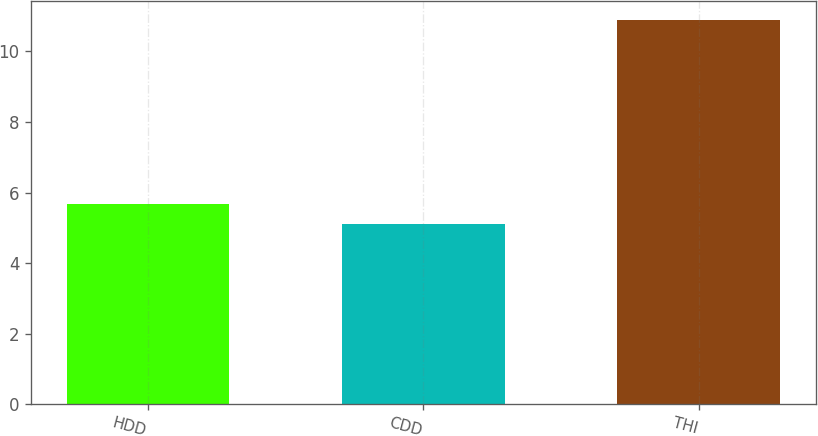Convert chart to OTSL. <chart><loc_0><loc_0><loc_500><loc_500><bar_chart><fcel>HDD<fcel>CDD<fcel>THI<nl><fcel>5.68<fcel>5.1<fcel>10.9<nl></chart> 